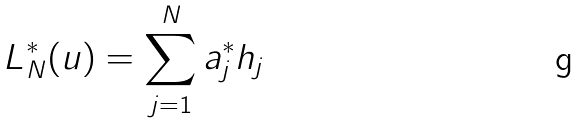<formula> <loc_0><loc_0><loc_500><loc_500>L _ { N } ^ { * } ( u ) = \sum _ { j = 1 } ^ { N } a _ { j } ^ { * } h _ { j }</formula> 